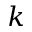Convert formula to latex. <formula><loc_0><loc_0><loc_500><loc_500>k</formula> 